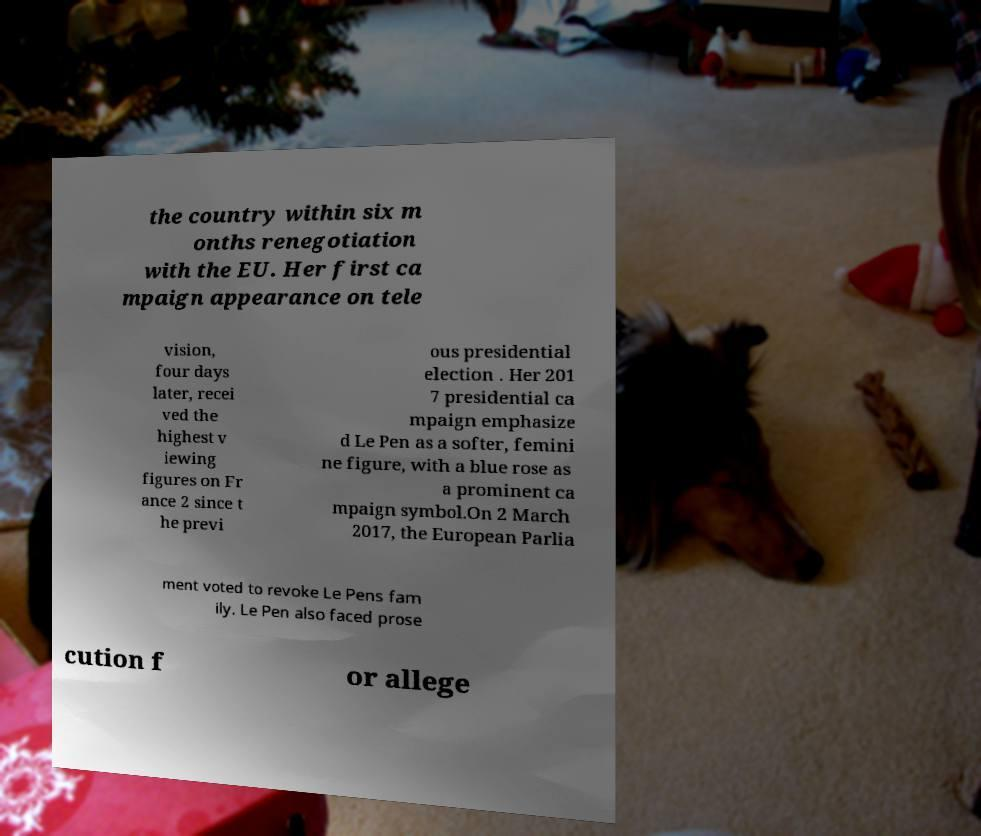Can you accurately transcribe the text from the provided image for me? the country within six m onths renegotiation with the EU. Her first ca mpaign appearance on tele vision, four days later, recei ved the highest v iewing figures on Fr ance 2 since t he previ ous presidential election . Her 201 7 presidential ca mpaign emphasize d Le Pen as a softer, femini ne figure, with a blue rose as a prominent ca mpaign symbol.On 2 March 2017, the European Parlia ment voted to revoke Le Pens fam ily. Le Pen also faced prose cution f or allege 